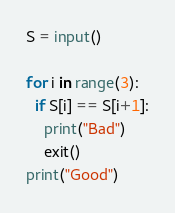Convert code to text. <code><loc_0><loc_0><loc_500><loc_500><_Python_>S = input()

for i in range(3):
  if S[i] == S[i+1]:
    print("Bad")
    exit()
print("Good")</code> 